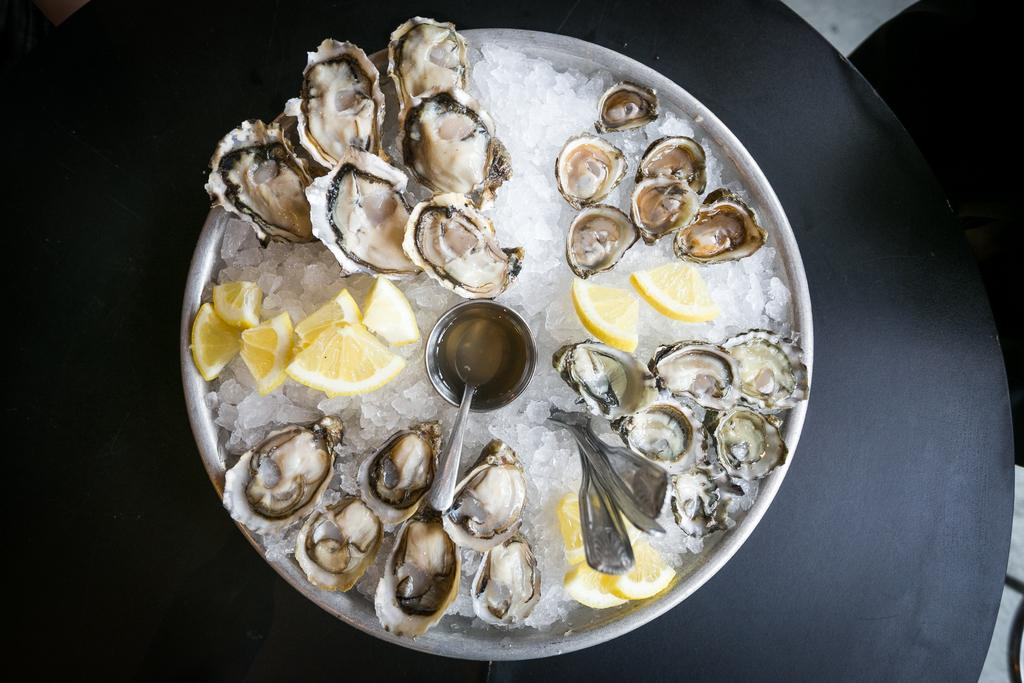What type of food can be seen in the image? There is seafood in the image. What is the seafood placed in? There is a bowl in the image. What utensil is present in the image? There is a spoon in the image. What is the seafood served on? There is a plate in the image. What is the color of the surface the items are on? The surface the items are on is black in color. Can you tell me how many squirrels are sitting on the plate in the image? There are no squirrels present in the image; it features seafood, a bowl, a spoon, and a plate on a black surface. What type of chicken is being served on the plate in the image? There is no chicken present in the image; it features seafood, a bowl, a spoon, and a plate on a black surface. 